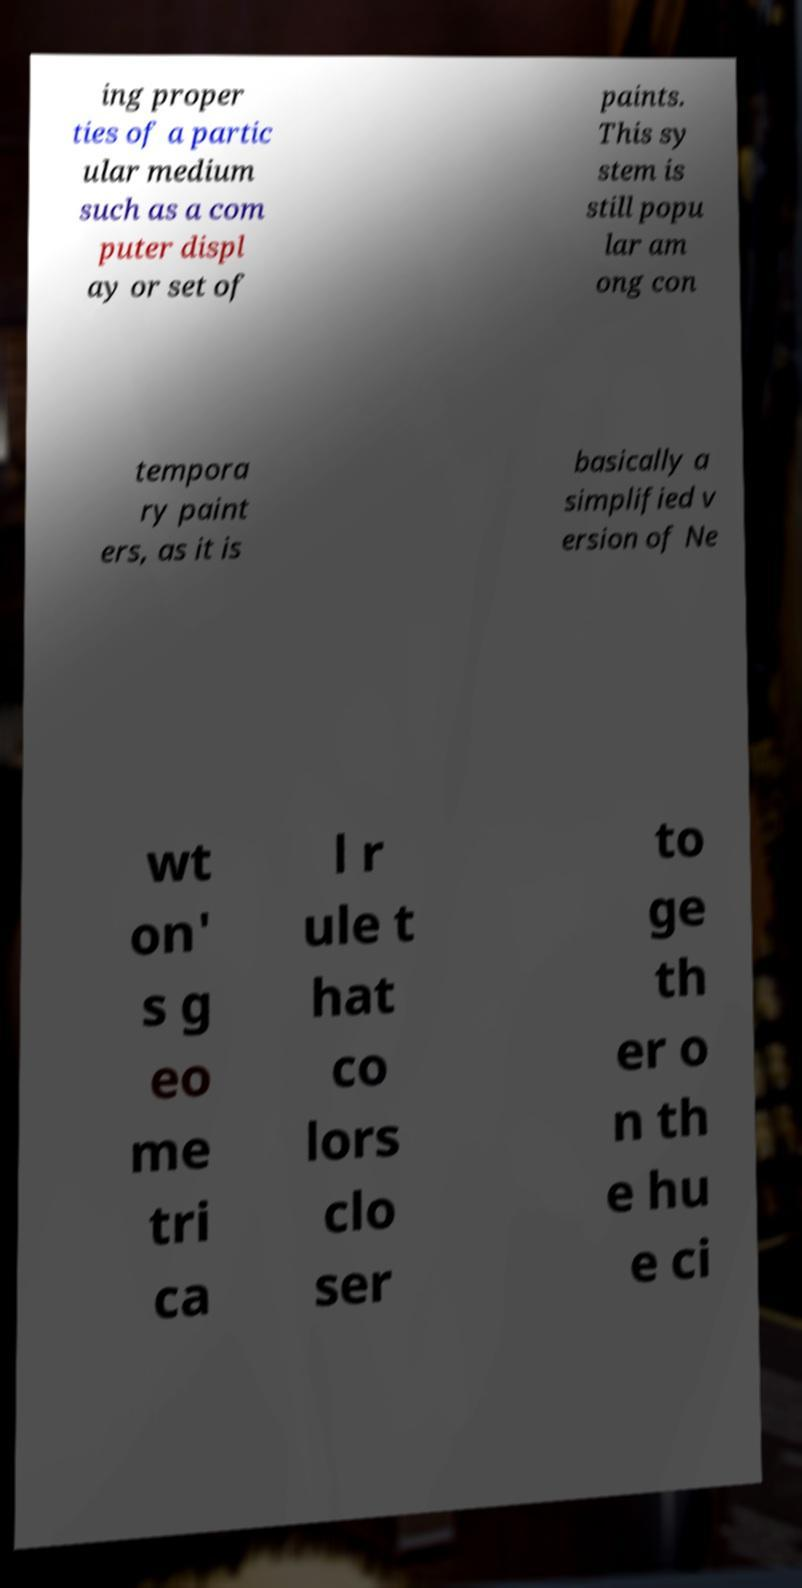Could you assist in decoding the text presented in this image and type it out clearly? ing proper ties of a partic ular medium such as a com puter displ ay or set of paints. This sy stem is still popu lar am ong con tempora ry paint ers, as it is basically a simplified v ersion of Ne wt on' s g eo me tri ca l r ule t hat co lors clo ser to ge th er o n th e hu e ci 